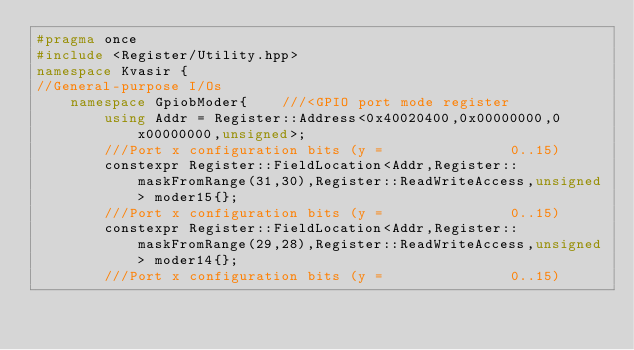Convert code to text. <code><loc_0><loc_0><loc_500><loc_500><_C++_>#pragma once 
#include <Register/Utility.hpp>
namespace Kvasir {
//General-purpose I/Os
    namespace GpiobModer{    ///<GPIO port mode register
        using Addr = Register::Address<0x40020400,0x00000000,0x00000000,unsigned>;
        ///Port x configuration bits (y =               0..15)
        constexpr Register::FieldLocation<Addr,Register::maskFromRange(31,30),Register::ReadWriteAccess,unsigned> moder15{}; 
        ///Port x configuration bits (y =               0..15)
        constexpr Register::FieldLocation<Addr,Register::maskFromRange(29,28),Register::ReadWriteAccess,unsigned> moder14{}; 
        ///Port x configuration bits (y =               0..15)</code> 